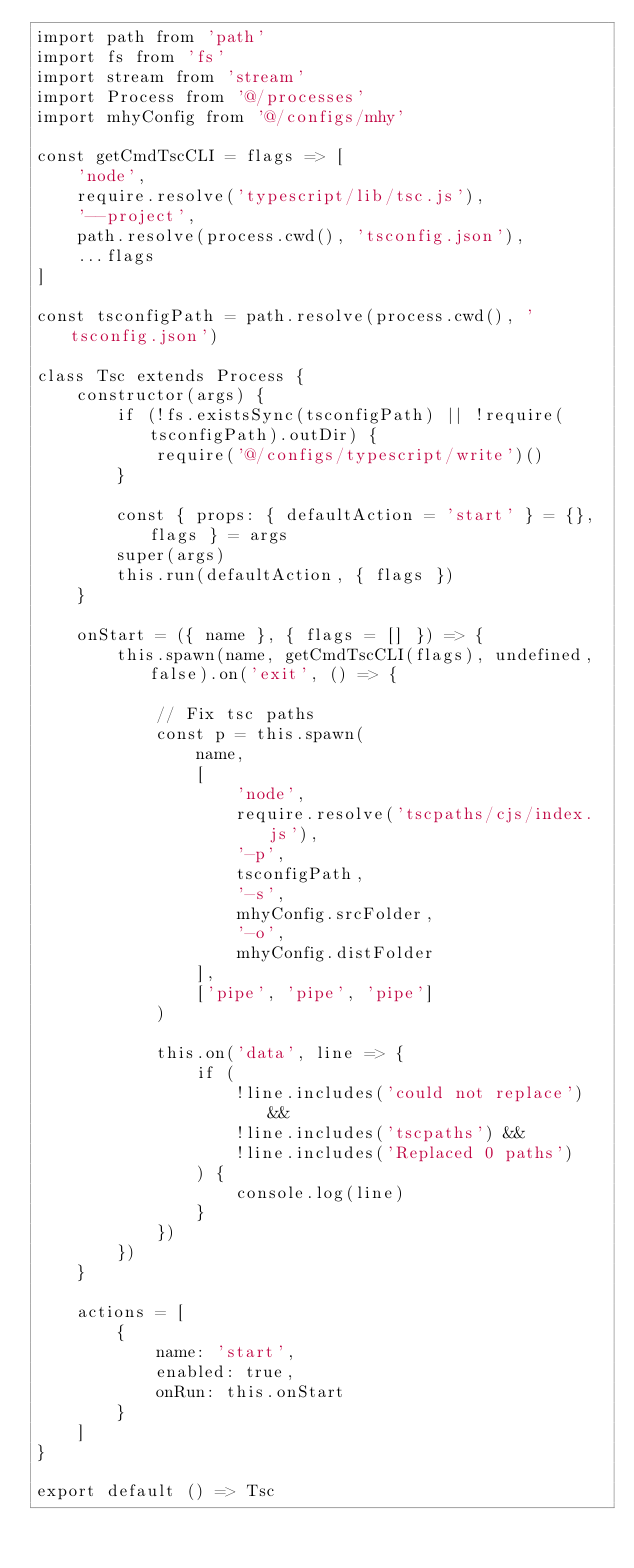<code> <loc_0><loc_0><loc_500><loc_500><_JavaScript_>import path from 'path'
import fs from 'fs'
import stream from 'stream'
import Process from '@/processes'
import mhyConfig from '@/configs/mhy'

const getCmdTscCLI = flags => [
    'node',
    require.resolve('typescript/lib/tsc.js'),
    '--project',
    path.resolve(process.cwd(), 'tsconfig.json'),
    ...flags
]

const tsconfigPath = path.resolve(process.cwd(), 'tsconfig.json')

class Tsc extends Process {
    constructor(args) {
        if (!fs.existsSync(tsconfigPath) || !require(tsconfigPath).outDir) {
            require('@/configs/typescript/write')()
        }

        const { props: { defaultAction = 'start' } = {}, flags } = args
        super(args)
        this.run(defaultAction, { flags })
    }

    onStart = ({ name }, { flags = [] }) => {
        this.spawn(name, getCmdTscCLI(flags), undefined, false).on('exit', () => {

            // Fix tsc paths
            const p = this.spawn(
                name,
                [
                    'node',
                    require.resolve('tscpaths/cjs/index.js'),
                    '-p',
                    tsconfigPath,
                    '-s',
                    mhyConfig.srcFolder,
                    '-o',
                    mhyConfig.distFolder
                ],
                ['pipe', 'pipe', 'pipe']
            )

            this.on('data', line => {
                if (
                    !line.includes('could not replace') &&
                    !line.includes('tscpaths') &&
                    !line.includes('Replaced 0 paths')
                ) {
                    console.log(line)
                }
            })
        })
    }

    actions = [
        {
            name: 'start',
            enabled: true,
            onRun: this.onStart
        }
    ]
}

export default () => Tsc
</code> 